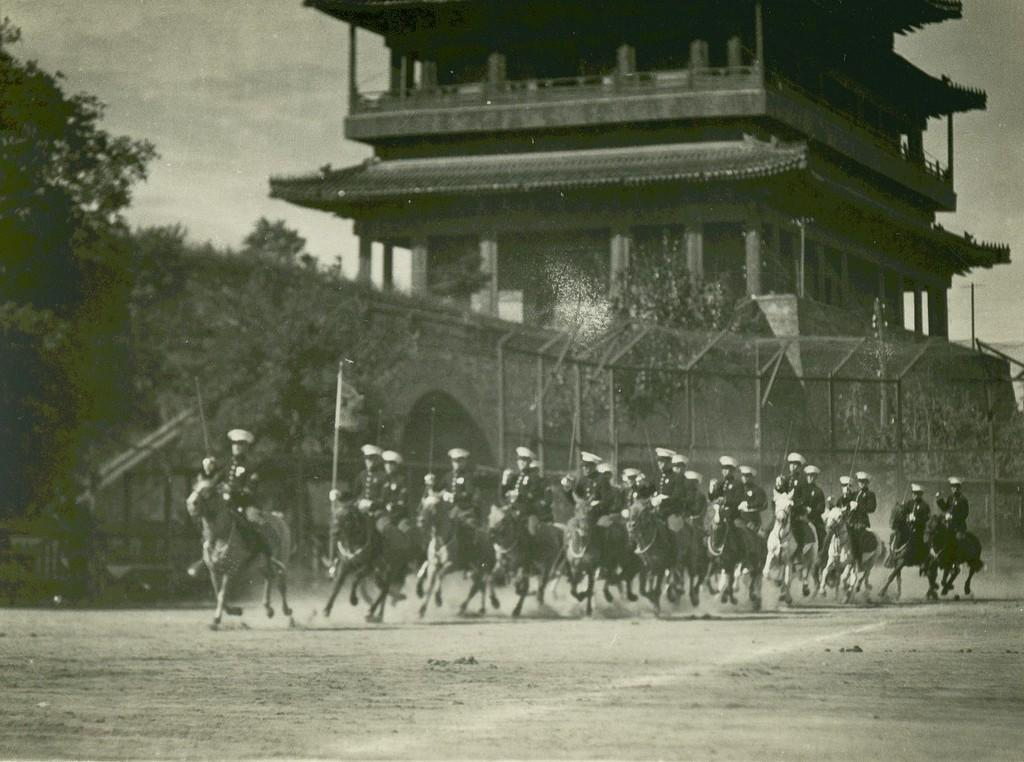What are the persons in the image doing? The persons in the image are riding horses. What are the persons wearing on their heads? The persons are wearing white caps. What can be seen in the background of the image? There is a fence, trees, and a building in the background of the image. What type of meat is being served on a plate in the image? There is no plate or meat present in the image; it features persons riding horses and wearing white caps. 